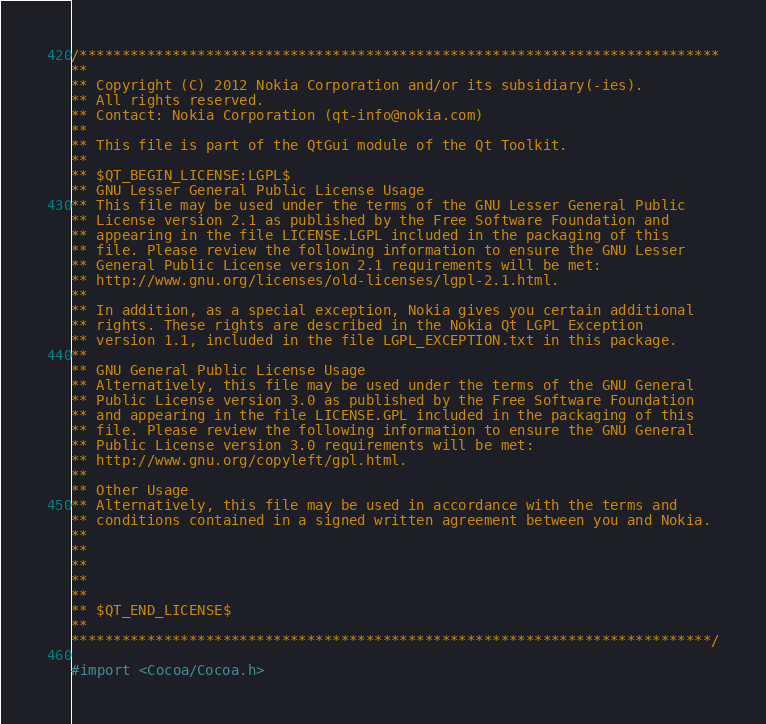<code> <loc_0><loc_0><loc_500><loc_500><_ObjectiveC_>/****************************************************************************
**
** Copyright (C) 2012 Nokia Corporation and/or its subsidiary(-ies).
** All rights reserved.
** Contact: Nokia Corporation (qt-info@nokia.com)
**
** This file is part of the QtGui module of the Qt Toolkit.
**
** $QT_BEGIN_LICENSE:LGPL$
** GNU Lesser General Public License Usage
** This file may be used under the terms of the GNU Lesser General Public
** License version 2.1 as published by the Free Software Foundation and
** appearing in the file LICENSE.LGPL included in the packaging of this
** file. Please review the following information to ensure the GNU Lesser
** General Public License version 2.1 requirements will be met:
** http://www.gnu.org/licenses/old-licenses/lgpl-2.1.html.
**
** In addition, as a special exception, Nokia gives you certain additional
** rights. These rights are described in the Nokia Qt LGPL Exception
** version 1.1, included in the file LGPL_EXCEPTION.txt in this package.
**
** GNU General Public License Usage
** Alternatively, this file may be used under the terms of the GNU General
** Public License version 3.0 as published by the Free Software Foundation
** and appearing in the file LICENSE.GPL included in the packaging of this
** file. Please review the following information to ensure the GNU General
** Public License version 3.0 requirements will be met:
** http://www.gnu.org/copyleft/gpl.html.
**
** Other Usage
** Alternatively, this file may be used in accordance with the terms and
** conditions contained in a signed written agreement between you and Nokia.
**
**
**
**
**
** $QT_END_LICENSE$
**
****************************************************************************/

#import <Cocoa/Cocoa.h></code> 